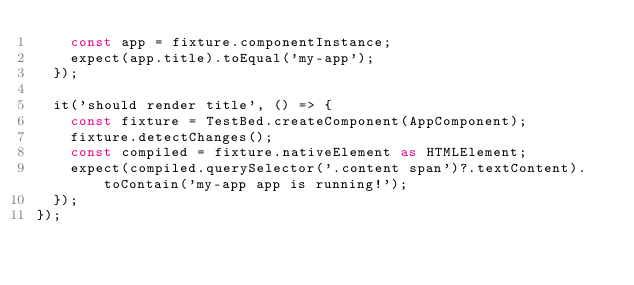Convert code to text. <code><loc_0><loc_0><loc_500><loc_500><_TypeScript_>    const app = fixture.componentInstance;
    expect(app.title).toEqual('my-app');
  });

  it('should render title', () => {
    const fixture = TestBed.createComponent(AppComponent);
    fixture.detectChanges();
    const compiled = fixture.nativeElement as HTMLElement;
    expect(compiled.querySelector('.content span')?.textContent).toContain('my-app app is running!');
  });
});
</code> 